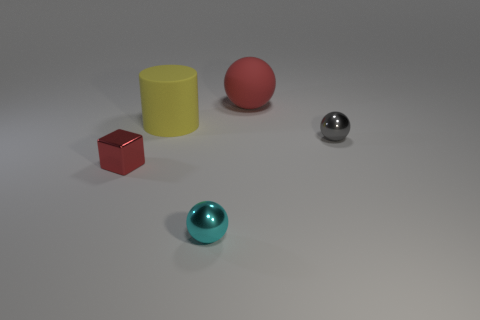What number of things are gray metallic spheres or gray spheres that are behind the tiny red cube?
Provide a succinct answer. 1. Are there fewer large yellow rubber cylinders than small metallic balls?
Ensure brevity in your answer.  Yes. There is a small shiny ball that is in front of the small shiny ball to the right of the large matte thing right of the cyan metal object; what color is it?
Your answer should be compact. Cyan. Is the large yellow thing made of the same material as the cyan sphere?
Give a very brief answer. No. What number of matte things are to the left of the cyan metallic sphere?
Your response must be concise. 1. There is a gray metal object that is the same shape as the red matte thing; what is its size?
Offer a very short reply. Small. How many yellow things are either rubber things or small metallic blocks?
Provide a short and direct response. 1. There is a big thing that is to the right of the cyan sphere; what number of things are to the right of it?
Provide a succinct answer. 1. What number of other things are the same shape as the small cyan thing?
Keep it short and to the point. 2. There is a big object that is the same color as the small block; what is it made of?
Provide a short and direct response. Rubber. 